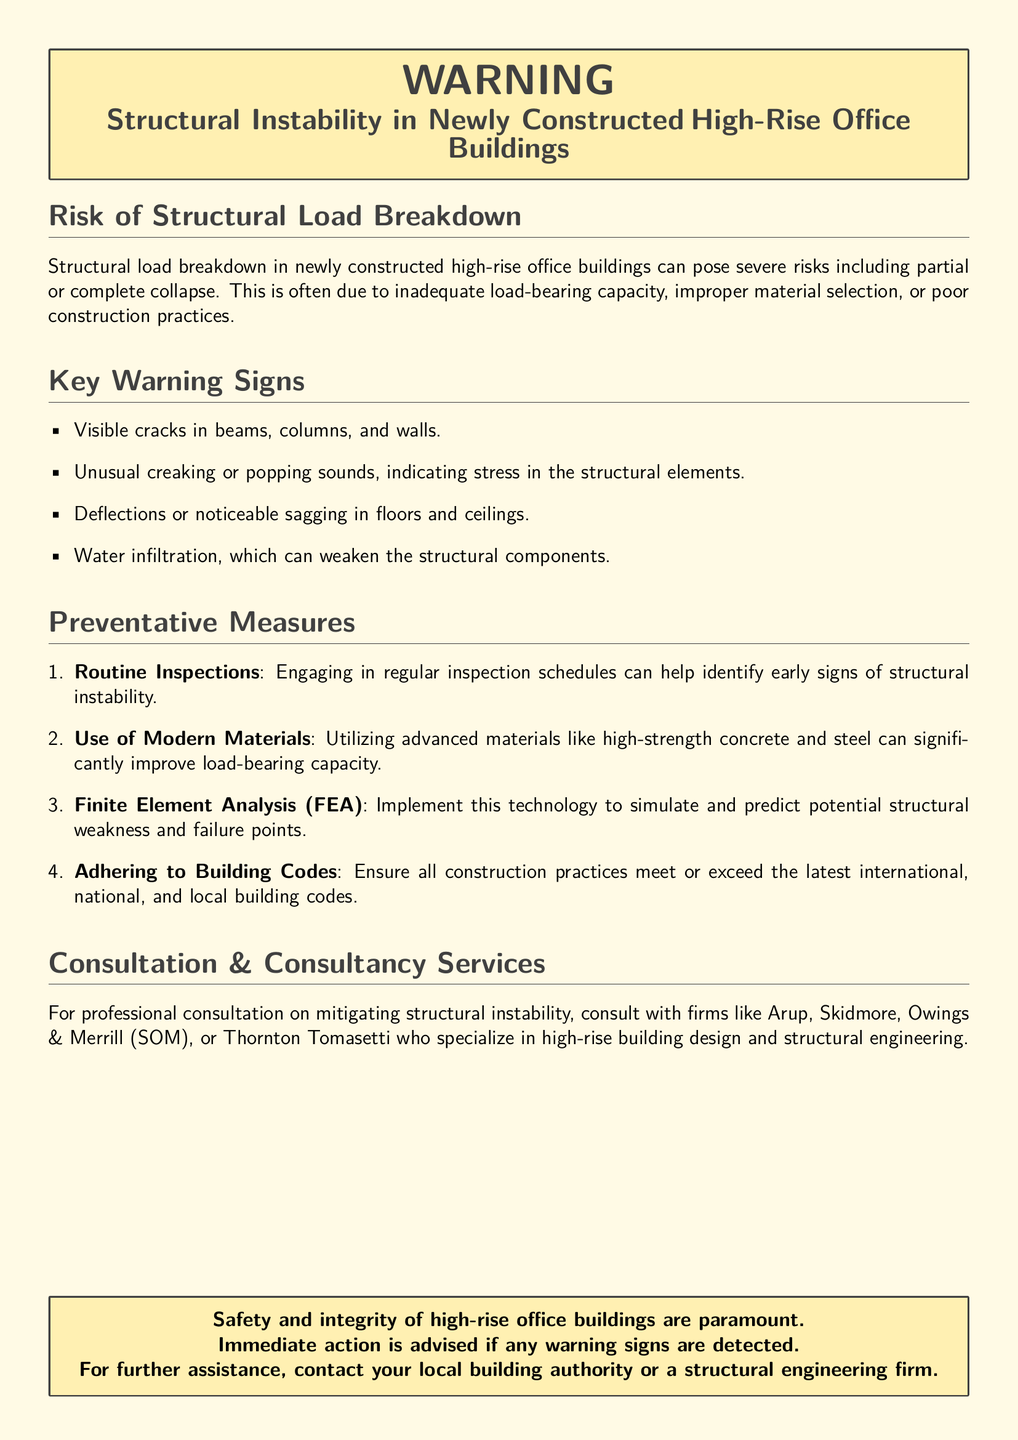What is the main risk mentioned in the document? The main risk described in the document refers to the potential for partial or complete collapse of the building, which is categorized under structural load breakdown.
Answer: Structural load breakdown What should you do if you notice water infiltration? The document emphasizes immediate action if warning signs are detected, thus implying that detecting water infiltration should prompt urgent assessment.
Answer: Immediate action What is one key sign of structural instability? The document lists visible cracks in beams, columns, and walls as a primary warning sign of structural instability.
Answer: Visible cracks Which organization is mentioned for consultation services? The document names firms like Arup, Skidmore, Owings & Merrill (SOM), and Thornton Tomasetti as specialists for consultation on structural instability.
Answer: Arup What type of analysis is suggested to predict structural weaknesses? The document recommends the use of Finite Element Analysis (FEA) to simulate and predict potential structural weaknesses.
Answer: Finite Element Analysis (FEA) How many key warning signs are listed in the document? The document enumerates four key warning signs related to structural instability, indicating the specific issues to look out for.
Answer: Four Which modern materials are encouraged for use in construction? The document advises the use of advanced materials, specifically highlighting high-strength concrete and steel.
Answer: High-strength concrete and steel What is the color theme of the warning label? The document utilizes a color scheme with a specific shade of yellow designated for warnings, complemented by dark gray for text.
Answer: Yellow and dark gray 